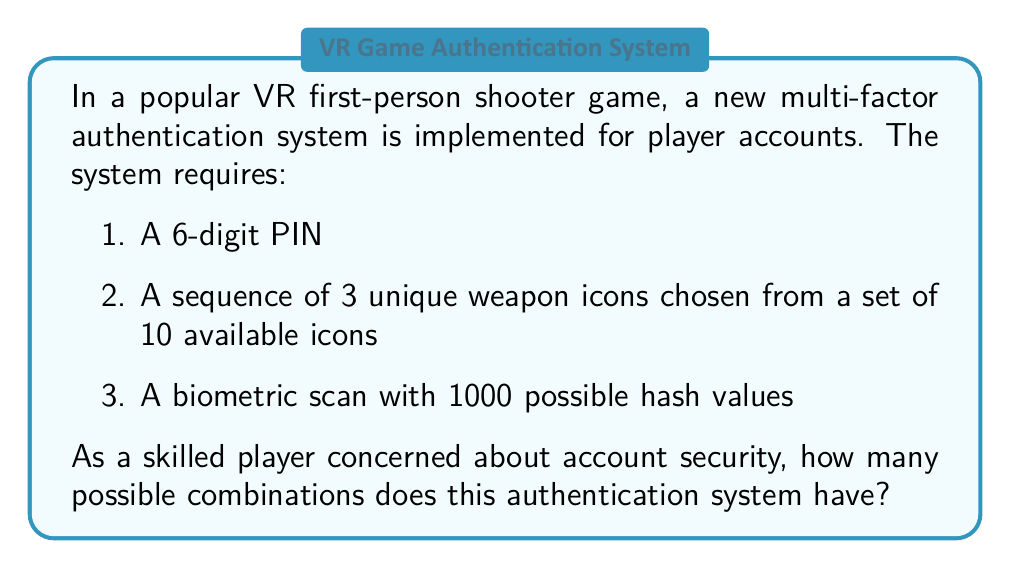Can you answer this question? Let's break this down step-by-step:

1. 6-digit PIN:
   - Each digit can be any number from 0 to 9
   - Total possibilities = $10^6$

2. Sequence of 3 unique weapon icons from 10:
   - This is a permutation problem (order matters)
   - We calculate this using the formula: $P(10,3) = \frac{10!}{(10-3)!} = \frac{10!}{7!}$
   - $P(10,3) = 10 \times 9 \times 8 = 720$

3. Biometric scan:
   - 1000 possible hash values
   - Total possibilities = 1000

Now, we apply the multiplication principle. Since all these factors are independent and must occur together, we multiply the number of possibilities for each:

$$\text{Total combinations} = 10^6 \times 720 \times 1000$$

Simplifying:
$$\text{Total combinations} = 10^6 \times 720 \times 10^3 = 720 \times 10^9$$

Therefore, the total number of possible combinations is $720,000,000,000$.
Answer: $720,000,000,000$ 